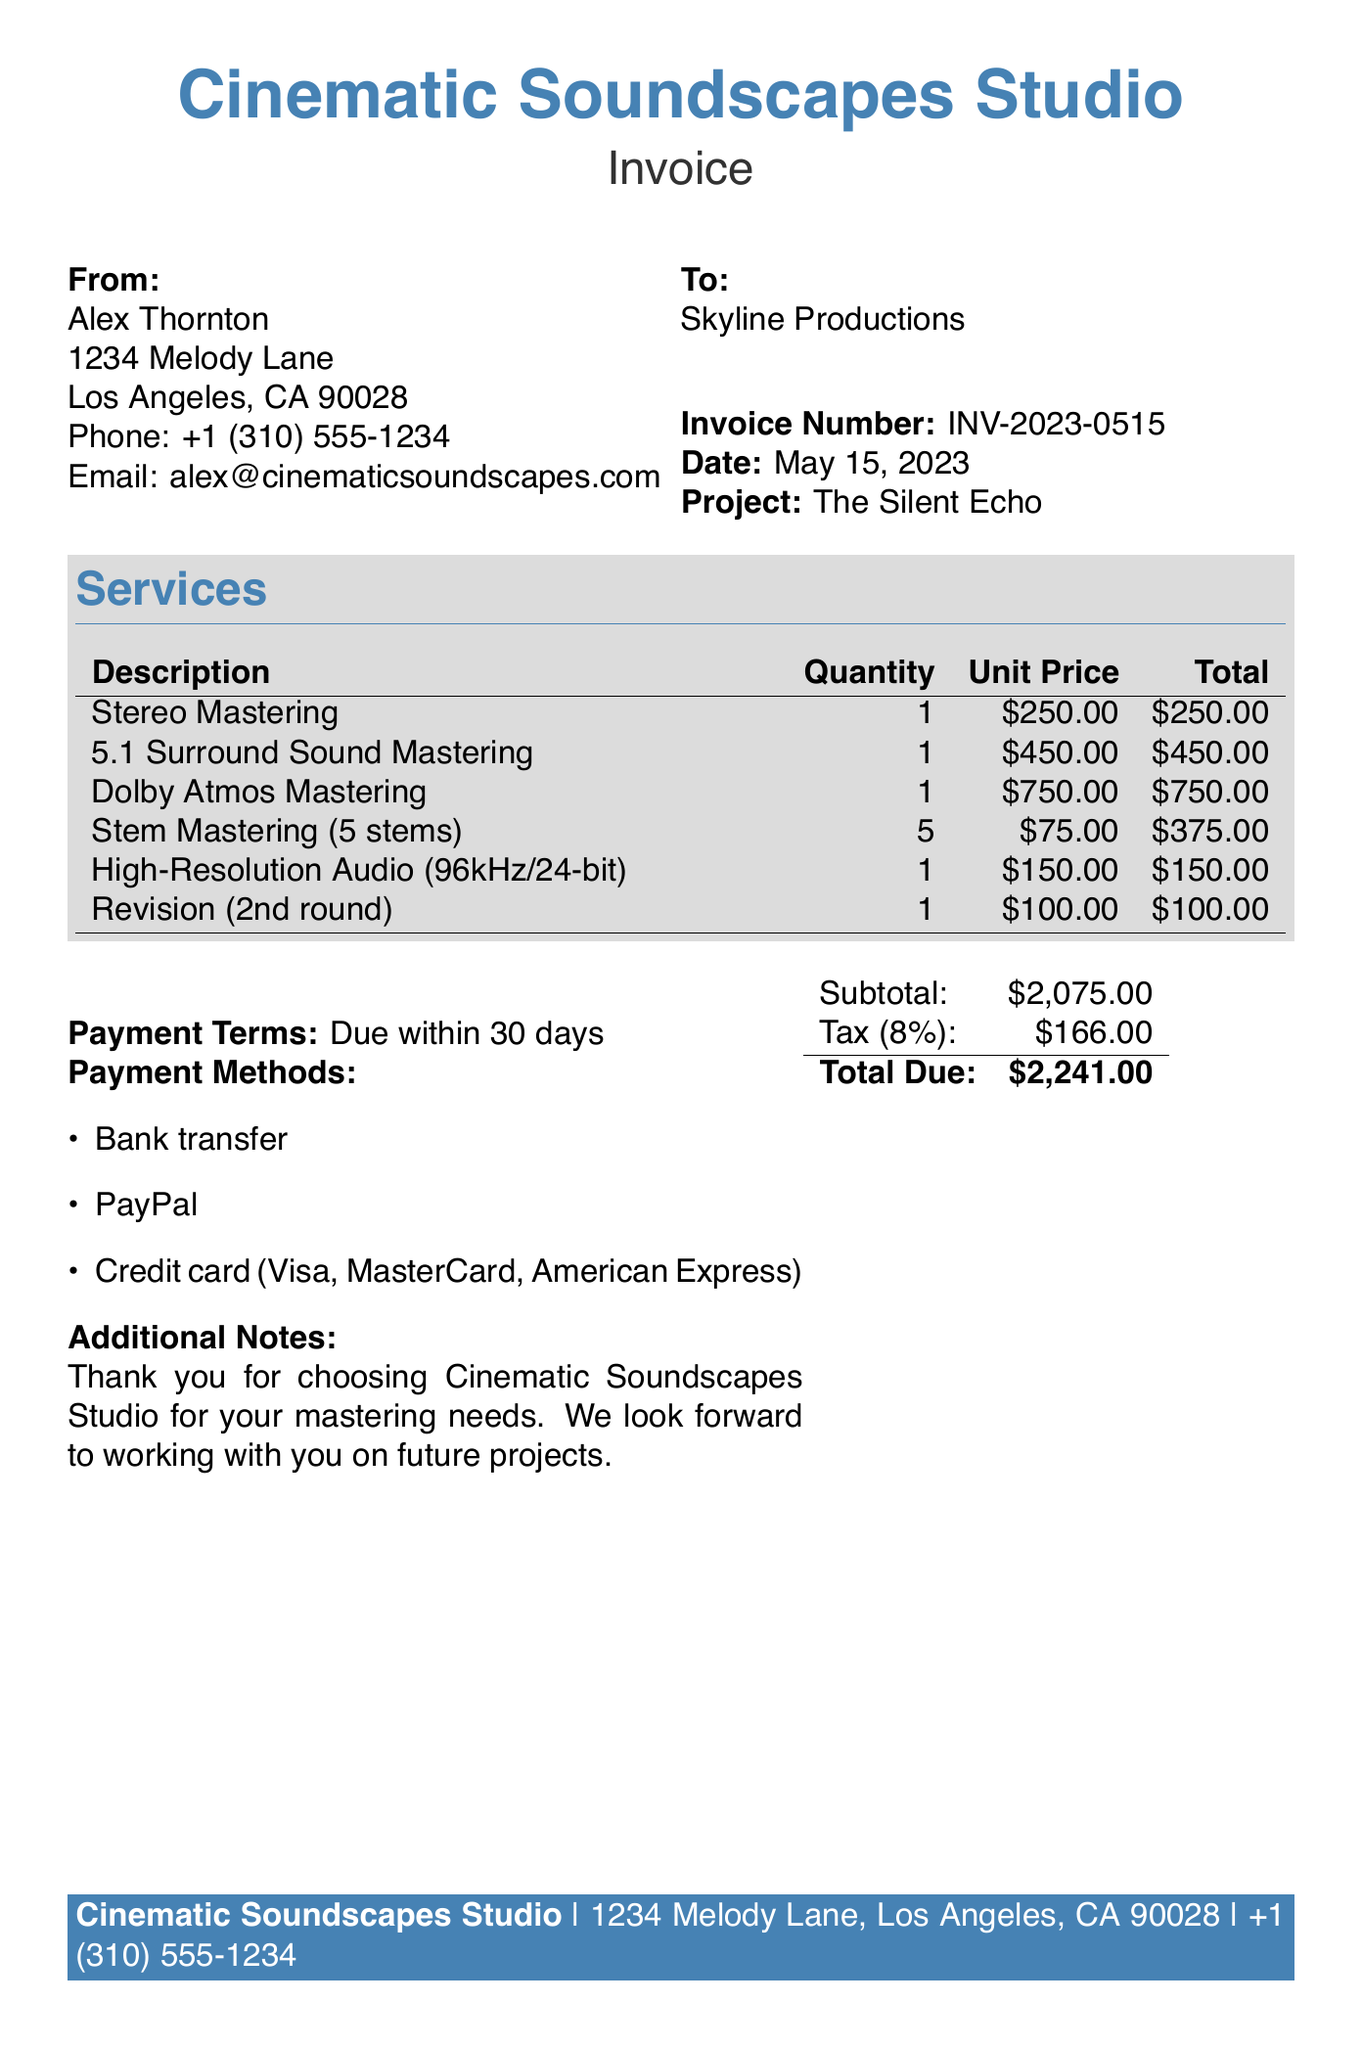What is the invoice number? The invoice number is clearly stated in the document for easy reference.
Answer: INV-2023-0515 Who is the producer? The document provides the name of the producer who issued the invoice.
Answer: Alex Thornton What is the total amount due? The total amount due is calculated including the subtotal and tax.
Answer: $2,241.00 How many revisions were included? The document specifies the number of revisions requested by the client.
Answer: 1 What service costs the most? Analyzing the services listed reveals which service has the highest unit price.
Answer: Dolby Atmos Mastering What is the tax rate? The tax rate is mentioned to clarify the calculation of tax on the subtotal.
Answer: 8% What is the due date for payment? The payment terms specify when the payment is expected to be made.
Answer: Within 30 days Which audio format is specified as high-resolution? The document names a specific audio format that meets high-resolution requirements.
Answer: 96kHz/24-bit How many stems were used in the stem mastering service? The number of stems for this particular mastering service is detailed in the document.
Answer: 5 